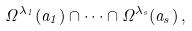<formula> <loc_0><loc_0><loc_500><loc_500>\Omega ^ { \lambda _ { 1 } } ( a _ { 1 } ) \cap \dots \cap \Omega ^ { \lambda _ { s } } ( a _ { s } ) \, ,</formula> 